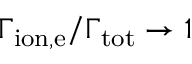<formula> <loc_0><loc_0><loc_500><loc_500>\Gamma _ { i o n , e } / \Gamma _ { t o t } \rightarrow 1</formula> 